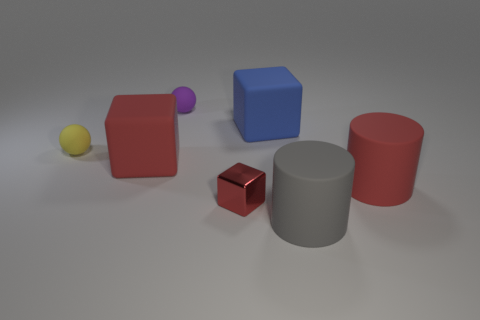Add 3 small yellow objects. How many objects exist? 10 Subtract all large cubes. How many cubes are left? 1 Subtract all red cylinders. How many cylinders are left? 1 Add 2 blocks. How many blocks are left? 5 Add 3 cyan balls. How many cyan balls exist? 3 Subtract 0 green blocks. How many objects are left? 7 Subtract all blocks. How many objects are left? 4 Subtract all yellow cubes. Subtract all cyan spheres. How many cubes are left? 3 Subtract all blue cylinders. How many yellow spheres are left? 1 Subtract all tiny cyan things. Subtract all tiny yellow spheres. How many objects are left? 6 